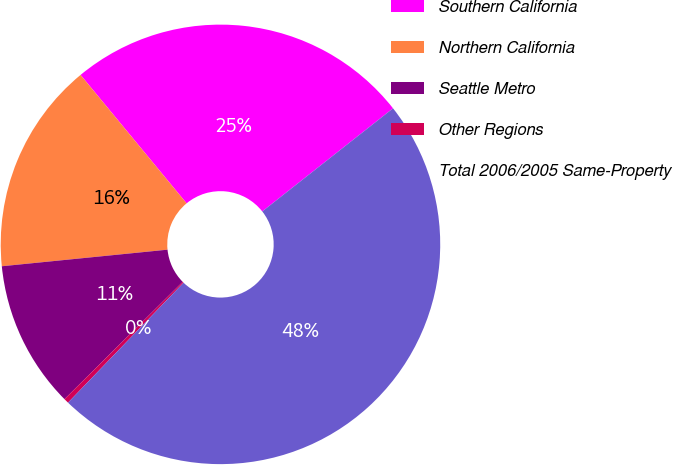Convert chart to OTSL. <chart><loc_0><loc_0><loc_500><loc_500><pie_chart><fcel>Southern California<fcel>Northern California<fcel>Seattle Metro<fcel>Other Regions<fcel>Total 2006/2005 Same-Property<nl><fcel>25.36%<fcel>15.6%<fcel>10.85%<fcel>0.36%<fcel>47.82%<nl></chart> 